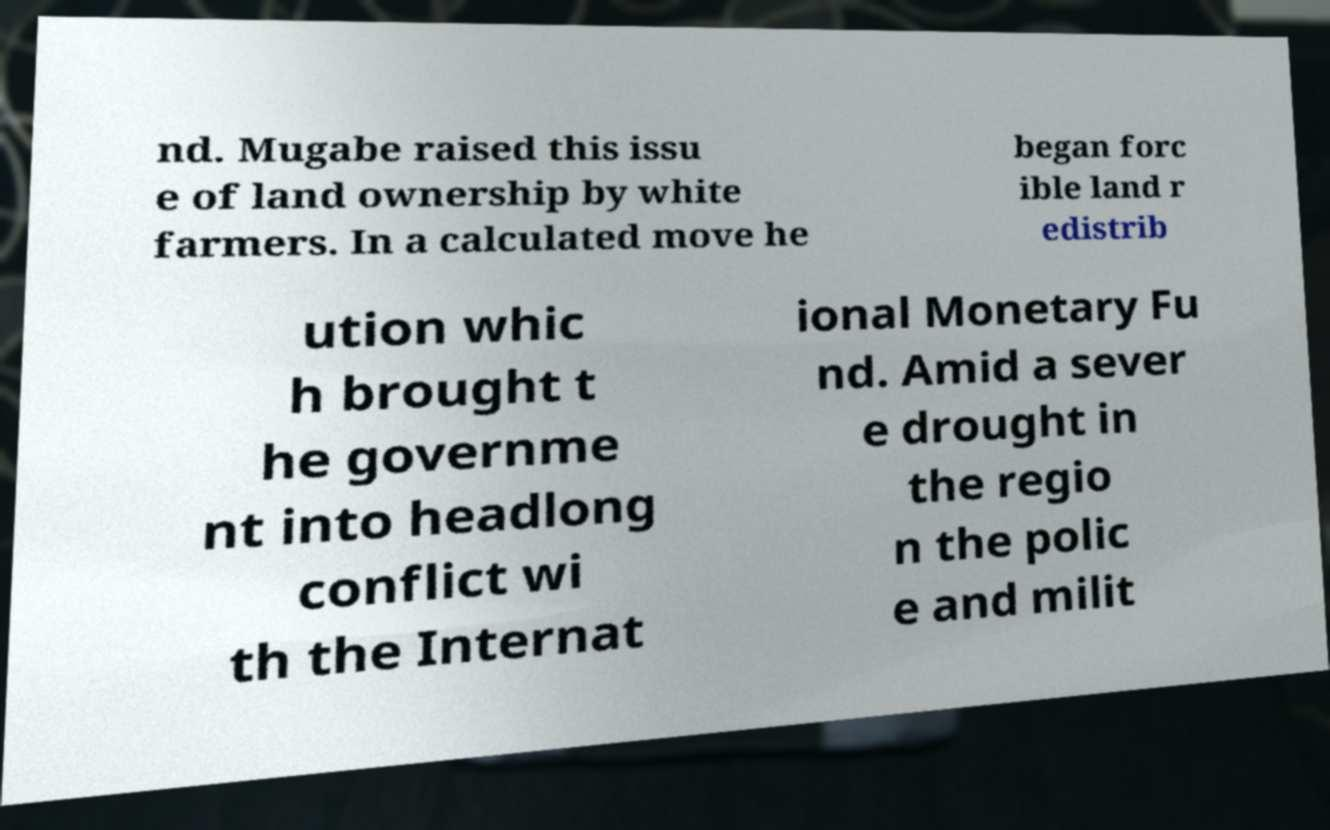Could you extract and type out the text from this image? nd. Mugabe raised this issu e of land ownership by white farmers. In a calculated move he began forc ible land r edistrib ution whic h brought t he governme nt into headlong conflict wi th the Internat ional Monetary Fu nd. Amid a sever e drought in the regio n the polic e and milit 